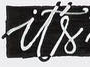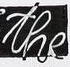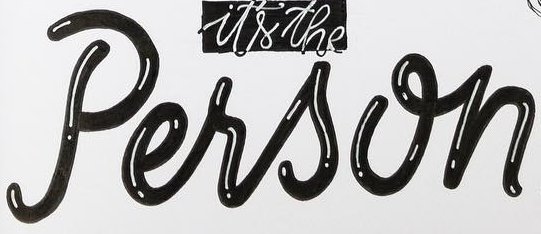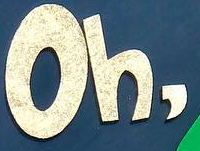What text is displayed in these images sequentially, separated by a semicolon? it's; the; Person; Oh, 